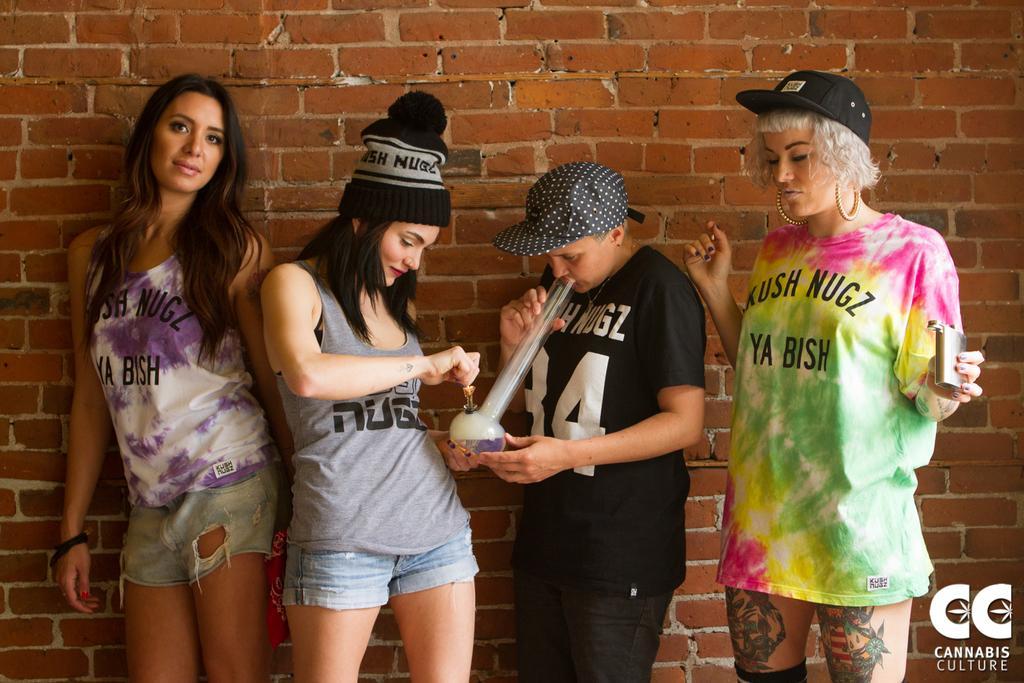How would you summarize this image in a sentence or two? In this picture we can see a group of people standing and a person in the black t shirt is holding an item. Behind the people there is a brick wall and on the image there is a watermark. 